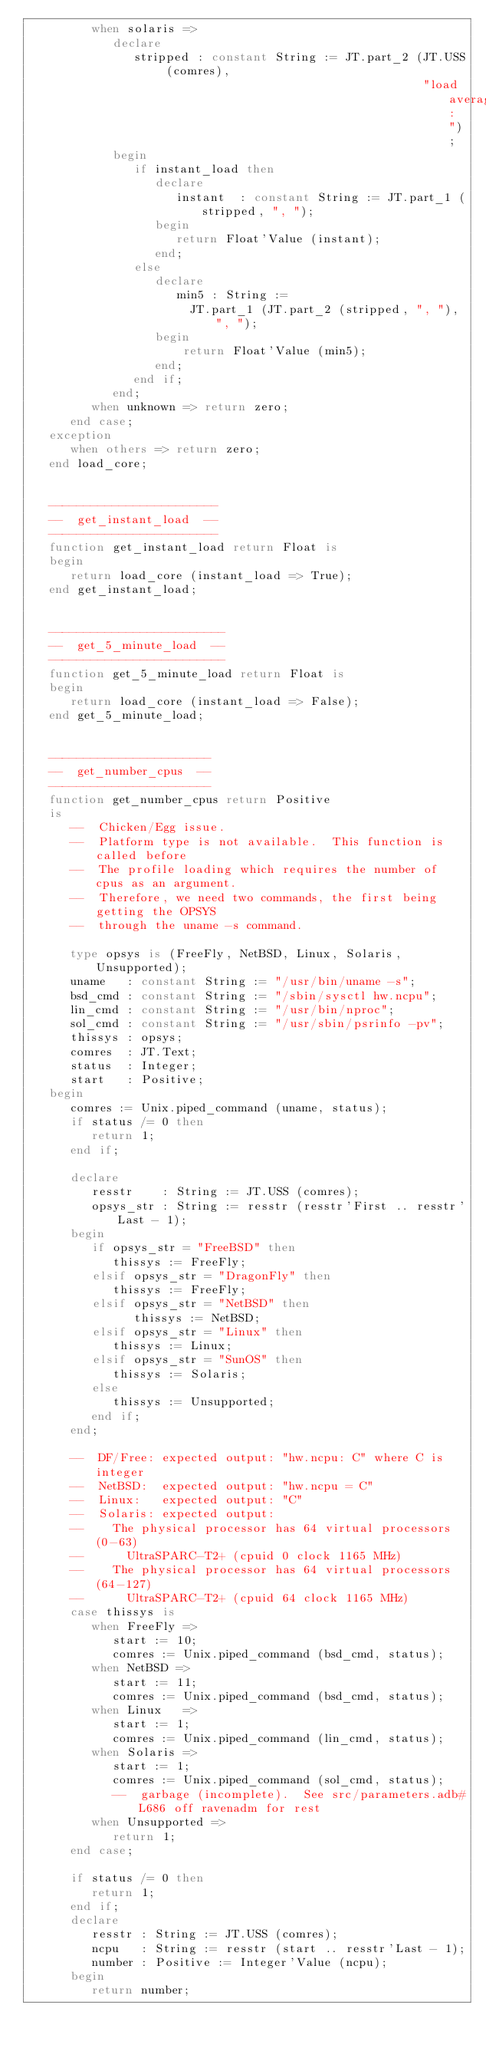Convert code to text. <code><loc_0><loc_0><loc_500><loc_500><_Ada_>         when solaris =>
            declare
               stripped : constant String := JT.part_2 (JT.USS (comres),
                                                        "load average: ");
            begin
               if instant_load then
                  declare
                     instant  : constant String := JT.part_1 (stripped, ", ");
                  begin
                     return Float'Value (instant);
                  end;
               else
                  declare
                     min5 : String :=
                       JT.part_1 (JT.part_2 (stripped, ", "), ", ");
                  begin
                      return Float'Value (min5);
                  end;
               end if;
            end;
         when unknown => return zero;
      end case;
   exception
      when others => return zero;
   end load_core;


   ------------------------
   --  get_instant_load  --
   ------------------------
   function get_instant_load return Float is
   begin
      return load_core (instant_load => True);
   end get_instant_load;


   -------------------------
   --  get_5_minute_load  --
   -------------------------
   function get_5_minute_load return Float is
   begin
      return load_core (instant_load => False);
   end get_5_minute_load;


   -----------------------
   --  get_number_cpus  --
   -----------------------
   function get_number_cpus return Positive
   is
      --  Chicken/Egg issue.
      --  Platform type is not available.  This function is called before
      --  The profile loading which requires the number of cpus as an argument.
      --  Therefore, we need two commands, the first being getting the OPSYS
      --  through the uname -s command.

      type opsys is (FreeFly, NetBSD, Linux, Solaris, Unsupported);
      uname   : constant String := "/usr/bin/uname -s";
      bsd_cmd : constant String := "/sbin/sysctl hw.ncpu";
      lin_cmd : constant String := "/usr/bin/nproc";
      sol_cmd : constant String := "/usr/sbin/psrinfo -pv";
      thissys : opsys;
      comres  : JT.Text;
      status  : Integer;
      start   : Positive;
   begin
      comres := Unix.piped_command (uname, status);
      if status /= 0 then
         return 1;
      end if;

      declare
         resstr    : String := JT.USS (comres);
         opsys_str : String := resstr (resstr'First .. resstr'Last - 1);
      begin
         if opsys_str = "FreeBSD" then
            thissys := FreeFly;
         elsif opsys_str = "DragonFly" then
            thissys := FreeFly;
         elsif opsys_str = "NetBSD" then
               thissys := NetBSD;
         elsif opsys_str = "Linux" then
            thissys := Linux;
         elsif opsys_str = "SunOS" then
            thissys := Solaris;
         else
            thissys := Unsupported;
         end if;
      end;

      --  DF/Free: expected output: "hw.ncpu: C" where C is integer
      --  NetBSD:  expected output: "hw.ncpu = C"
      --  Linux:   expected output: "C"
      --  Solaris: expected output:
      --    The physical processor has 64 virtual processors (0-63)
      --      UltraSPARC-T2+ (cpuid 0 clock 1165 MHz)
      --    The physical processor has 64 virtual processors (64-127)
      --      UltraSPARC-T2+ (cpuid 64 clock 1165 MHz)
      case thissys is
         when FreeFly =>
            start := 10;
            comres := Unix.piped_command (bsd_cmd, status);
         when NetBSD =>
            start := 11;
            comres := Unix.piped_command (bsd_cmd, status);
         when Linux   =>
            start := 1;
            comres := Unix.piped_command (lin_cmd, status);
         when Solaris =>
            start := 1;
            comres := Unix.piped_command (sol_cmd, status);
            --  garbage (incomplete).  See src/parameters.adb#L686 off ravenadm for rest
         when Unsupported =>
            return 1;
      end case;

      if status /= 0 then
         return 1;
      end if;
      declare
         resstr : String := JT.USS (comres);
         ncpu   : String := resstr (start .. resstr'Last - 1);
         number : Positive := Integer'Value (ncpu);
      begin
         return number;</code> 